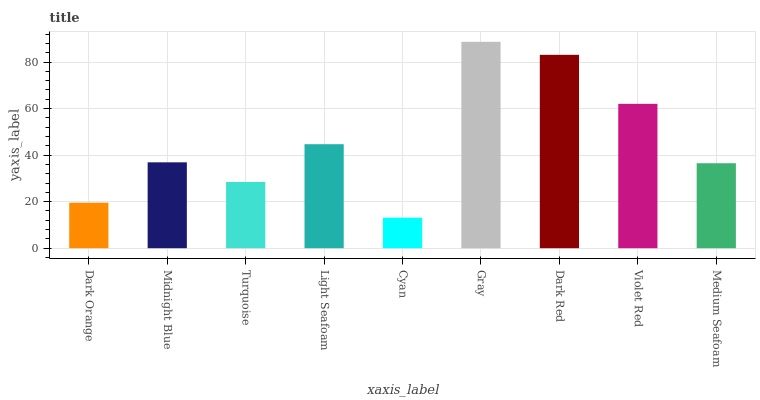Is Cyan the minimum?
Answer yes or no. Yes. Is Gray the maximum?
Answer yes or no. Yes. Is Midnight Blue the minimum?
Answer yes or no. No. Is Midnight Blue the maximum?
Answer yes or no. No. Is Midnight Blue greater than Dark Orange?
Answer yes or no. Yes. Is Dark Orange less than Midnight Blue?
Answer yes or no. Yes. Is Dark Orange greater than Midnight Blue?
Answer yes or no. No. Is Midnight Blue less than Dark Orange?
Answer yes or no. No. Is Midnight Blue the high median?
Answer yes or no. Yes. Is Midnight Blue the low median?
Answer yes or no. Yes. Is Violet Red the high median?
Answer yes or no. No. Is Violet Red the low median?
Answer yes or no. No. 